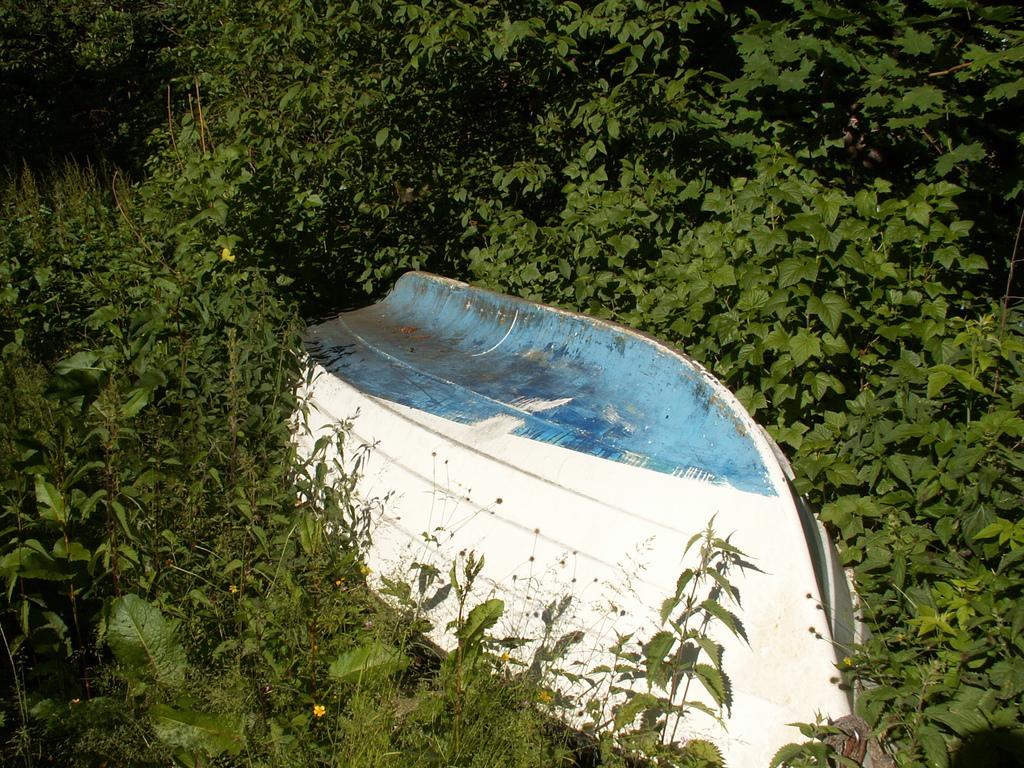In one or two sentences, can you explain what this image depicts? It seems like a boat in the middle of the image. In the background, we can see greenery. 